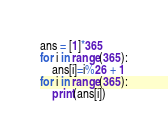Convert code to text. <code><loc_0><loc_0><loc_500><loc_500><_Python_>ans = [1]*365
for i in range(365):
    ans[i]=i%26 + 1
for i in range(365):
    print(ans[i])</code> 